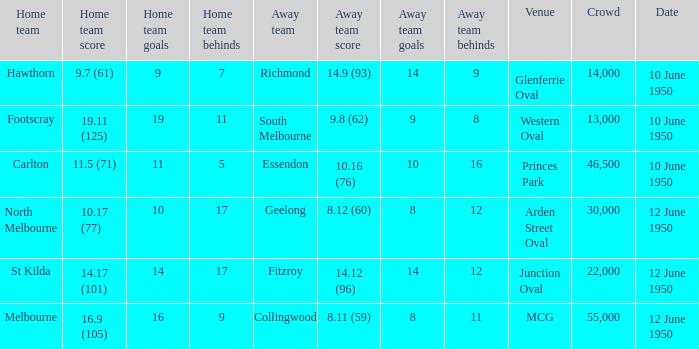What was the crowd when the VFL played MCG? 55000.0. 